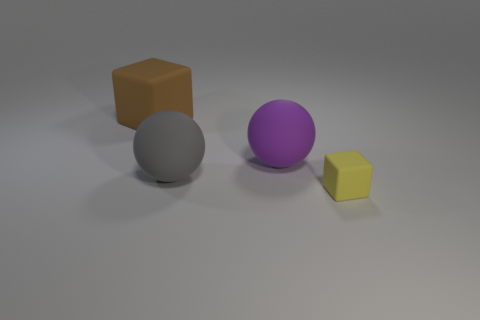There is a purple sphere that is the same size as the gray rubber object; what is its material?
Give a very brief answer. Rubber. Are there the same number of gray things that are right of the big purple thing and yellow objects?
Give a very brief answer. No. The brown block has what size?
Provide a succinct answer. Large. There is a cube to the right of the large brown rubber cube; how many tiny matte blocks are in front of it?
Your answer should be very brief. 0. There is a thing that is behind the gray rubber thing and in front of the big brown rubber thing; what shape is it?
Keep it short and to the point. Sphere. How many tiny things have the same color as the large block?
Provide a succinct answer. 0. Are there any large matte things that are behind the matte cube in front of the cube behind the purple matte ball?
Give a very brief answer. Yes. There is a thing that is both behind the gray sphere and right of the brown object; what size is it?
Ensure brevity in your answer.  Large. What number of small yellow things are the same material as the brown object?
Ensure brevity in your answer.  1. How many spheres are either brown things or big matte things?
Your answer should be very brief. 2. 